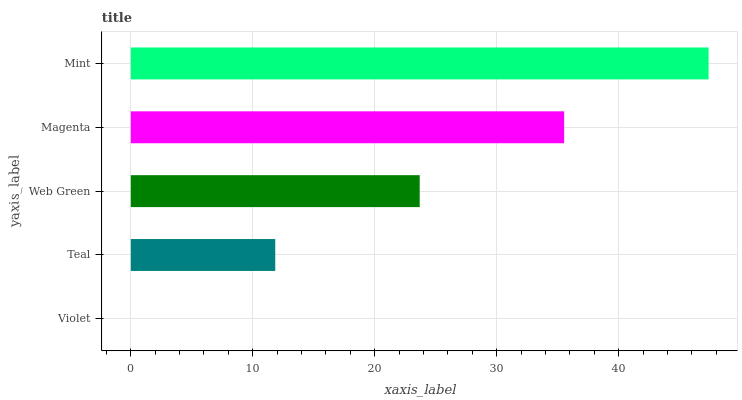Is Violet the minimum?
Answer yes or no. Yes. Is Mint the maximum?
Answer yes or no. Yes. Is Teal the minimum?
Answer yes or no. No. Is Teal the maximum?
Answer yes or no. No. Is Teal greater than Violet?
Answer yes or no. Yes. Is Violet less than Teal?
Answer yes or no. Yes. Is Violet greater than Teal?
Answer yes or no. No. Is Teal less than Violet?
Answer yes or no. No. Is Web Green the high median?
Answer yes or no. Yes. Is Web Green the low median?
Answer yes or no. Yes. Is Violet the high median?
Answer yes or no. No. Is Mint the low median?
Answer yes or no. No. 